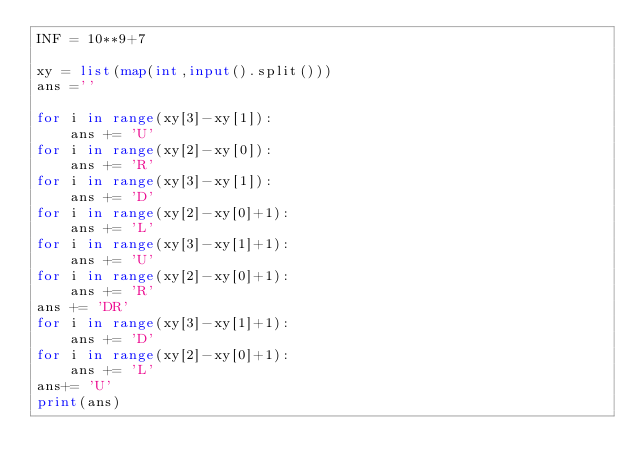Convert code to text. <code><loc_0><loc_0><loc_500><loc_500><_Python_>INF = 10**9+7

xy = list(map(int,input().split()))
ans =''

for i in range(xy[3]-xy[1]):
	ans += 'U'
for i in range(xy[2]-xy[0]):
	ans += 'R'
for i in range(xy[3]-xy[1]):
	ans += 'D'
for i in range(xy[2]-xy[0]+1):
	ans += 'L'
for i in range(xy[3]-xy[1]+1):
	ans += 'U'
for i in range(xy[2]-xy[0]+1):
	ans += 'R'
ans += 'DR'
for i in range(xy[3]-xy[1]+1):
	ans += 'D'
for i in range(xy[2]-xy[0]+1):
	ans += 'L'
ans+= 'U'
print(ans)</code> 